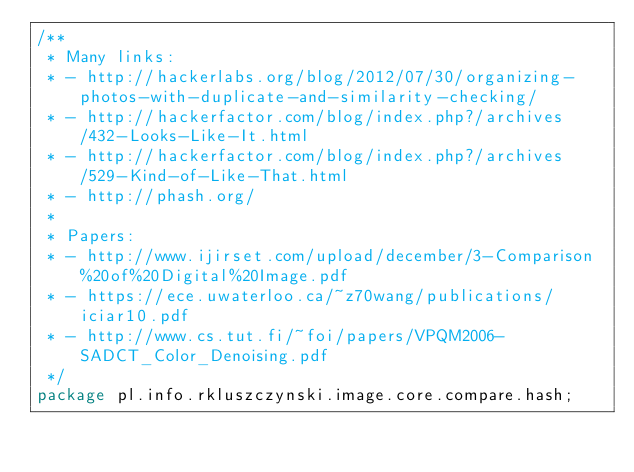<code> <loc_0><loc_0><loc_500><loc_500><_Java_>/**
 * Many links:
 * - http://hackerlabs.org/blog/2012/07/30/organizing-photos-with-duplicate-and-similarity-checking/
 * - http://hackerfactor.com/blog/index.php?/archives/432-Looks-Like-It.html
 * - http://hackerfactor.com/blog/index.php?/archives/529-Kind-of-Like-That.html
 * - http://phash.org/
 *
 * Papers:
 * - http://www.ijirset.com/upload/december/3-Comparison%20of%20Digital%20Image.pdf
 * - https://ece.uwaterloo.ca/~z70wang/publications/iciar10.pdf
 * - http://www.cs.tut.fi/~foi/papers/VPQM2006-SADCT_Color_Denoising.pdf
 */
package pl.info.rkluszczynski.image.core.compare.hash;</code> 